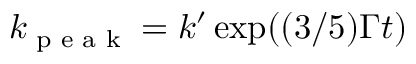Convert formula to latex. <formula><loc_0><loc_0><loc_500><loc_500>k _ { p e a k } = k ^ { \prime } \exp ( ( 3 / 5 ) \Gamma t )</formula> 